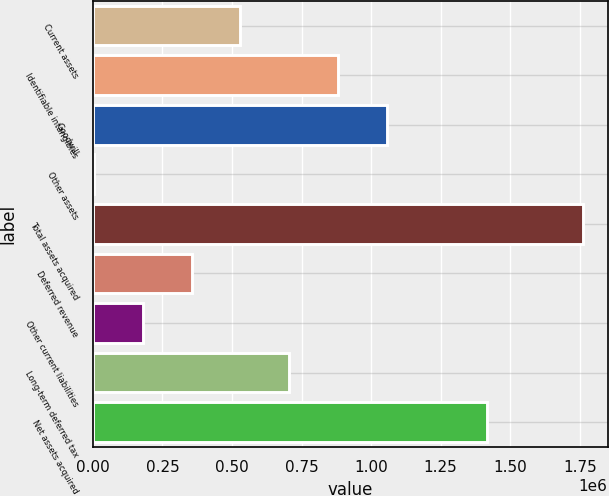<chart> <loc_0><loc_0><loc_500><loc_500><bar_chart><fcel>Current assets<fcel>Identifiable intangibles<fcel>Goodwill<fcel>Other assets<fcel>Total assets acquired<fcel>Deferred revenue<fcel>Other current liabilities<fcel>Long-term deferred tax<fcel>Net assets acquired<nl><fcel>530593<fcel>882526<fcel>1.05849e+06<fcel>2694<fcel>1.76236e+06<fcel>354627<fcel>178660<fcel>706559<fcel>1.41598e+06<nl></chart> 